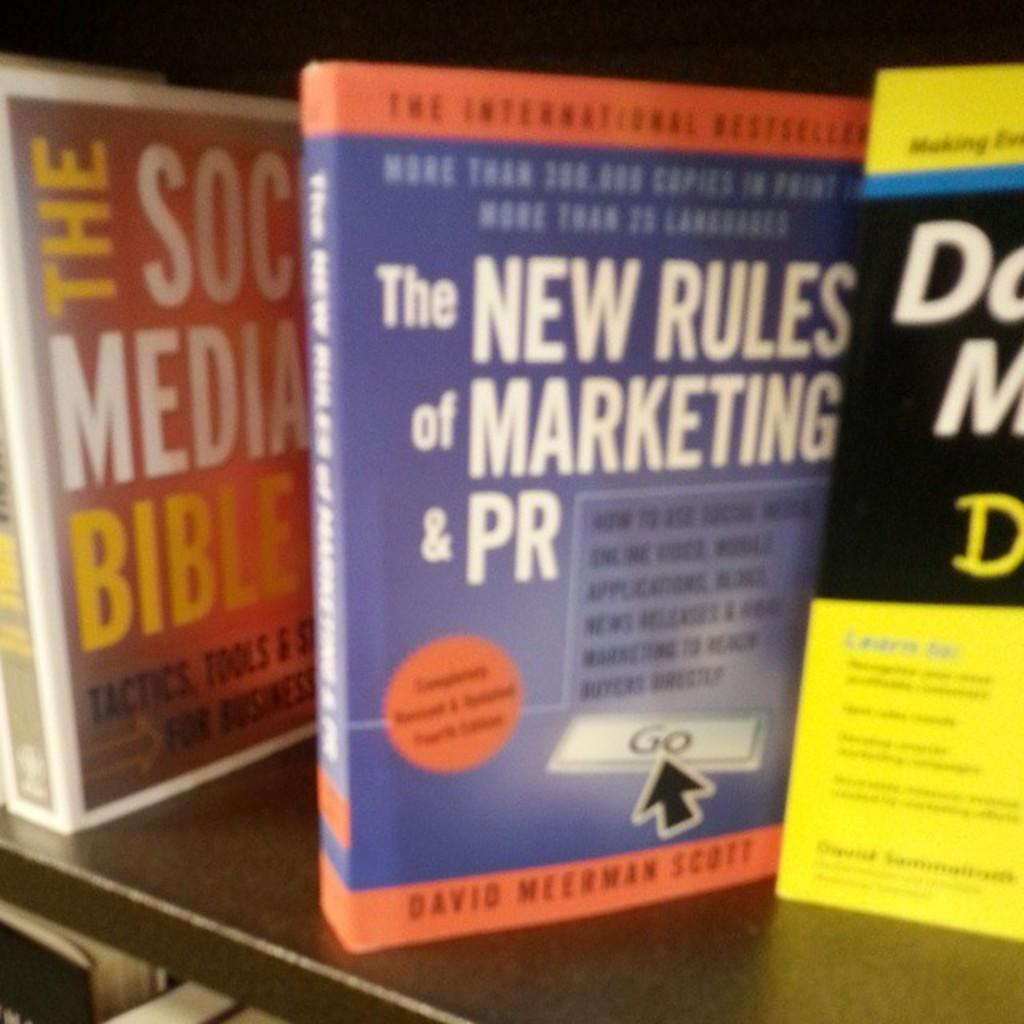<image>
Give a short and clear explanation of the subsequent image. A few books on a shelf, one it titled The New Rules of Marketing and PR. 